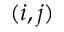<formula> <loc_0><loc_0><loc_500><loc_500>( i , j )</formula> 